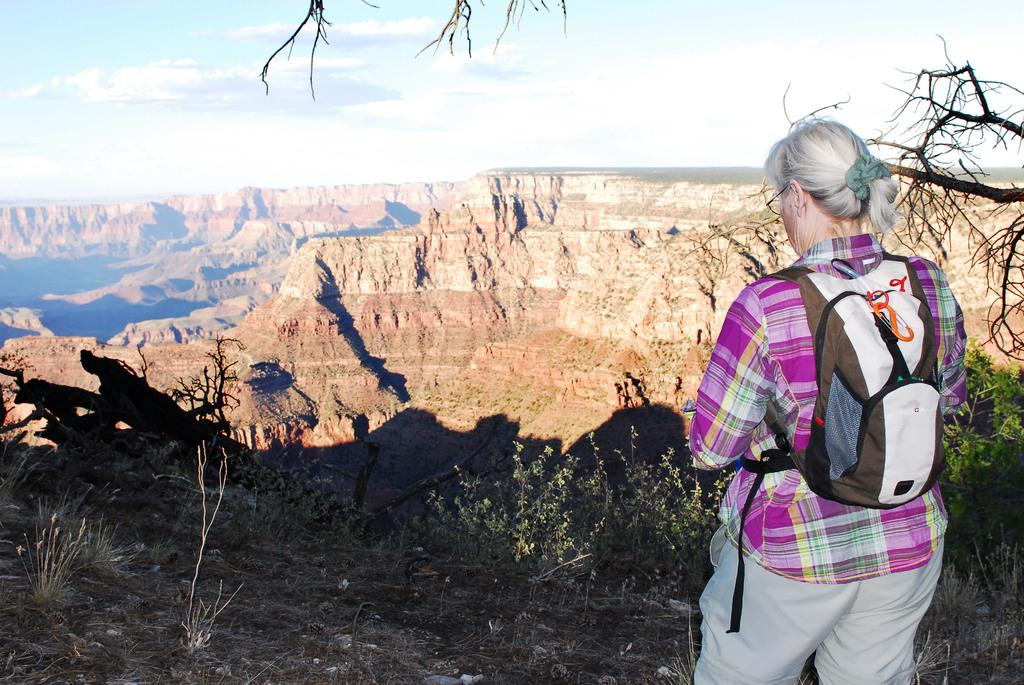What is the main subject of the image? There is a woman standing in the image. What is the woman wearing in the image? The woman is wearing a backpack. What type of natural environment is visible in the image? There are plants, trees, grass, and mountains visible in the image. What is visible in the background of the image? The sky is visible in the background of the image, with clouds present. What type of bone can be seen in the woman's hand in the image? There is no bone visible in the woman's hand or anywhere else in the image. What is the woman's interest in the truck parked nearby? There is no truck visible in the image, so it is not possible to determine the woman's interest in one. 